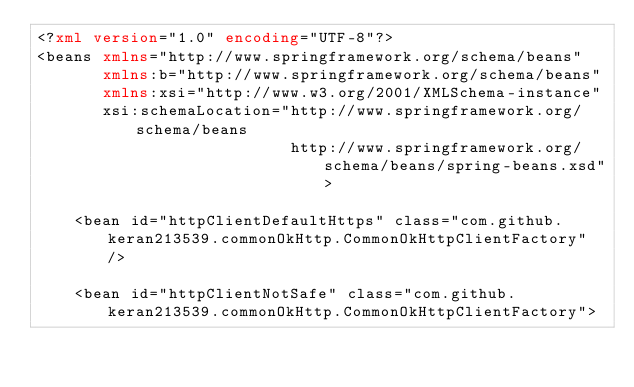<code> <loc_0><loc_0><loc_500><loc_500><_XML_><?xml version="1.0" encoding="UTF-8"?>
<beans xmlns="http://www.springframework.org/schema/beans" 
	   xmlns:b="http://www.springframework.org/schema/beans" 
	   xmlns:xsi="http://www.w3.org/2001/XMLSchema-instance" 
	   xsi:schemaLocation="http://www.springframework.org/schema/beans
                           http://www.springframework.org/schema/beans/spring-beans.xsd">

	<bean id="httpClientDefaultHttps" class="com.github.keran213539.commonOkHttp.CommonOkHttpClientFactory" />
	
	<bean id="httpClientNotSafe" class="com.github.keran213539.commonOkHttp.CommonOkHttpClientFactory"></code> 